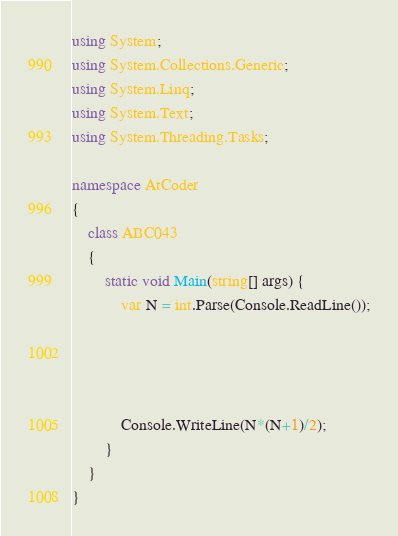Convert code to text. <code><loc_0><loc_0><loc_500><loc_500><_C#_>using System;
using System.Collections.Generic;
using System.Linq;
using System.Text;
using System.Threading.Tasks;

namespace AtCoder
{
    class ABC043
    {
        static void Main(string[] args) {
            var N = int.Parse(Console.ReadLine());




            Console.WriteLine(N*(N+1)/2);
        }
    }
}
</code> 